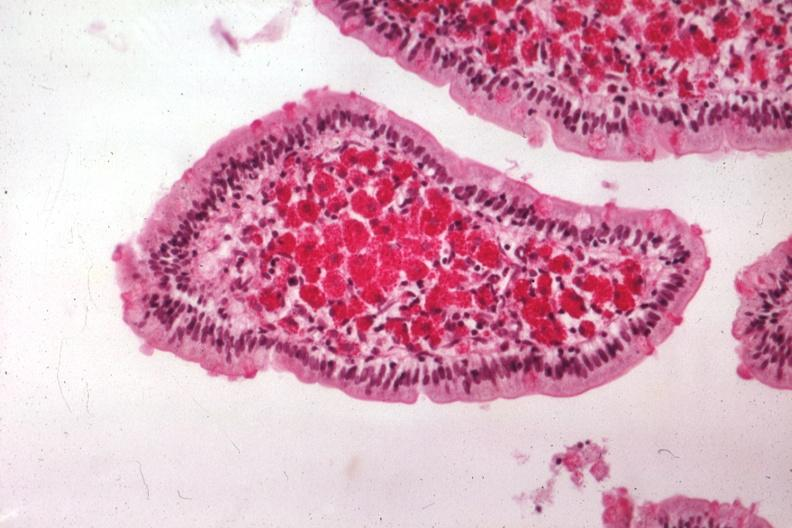what is present?
Answer the question using a single word or phrase. Intestine 